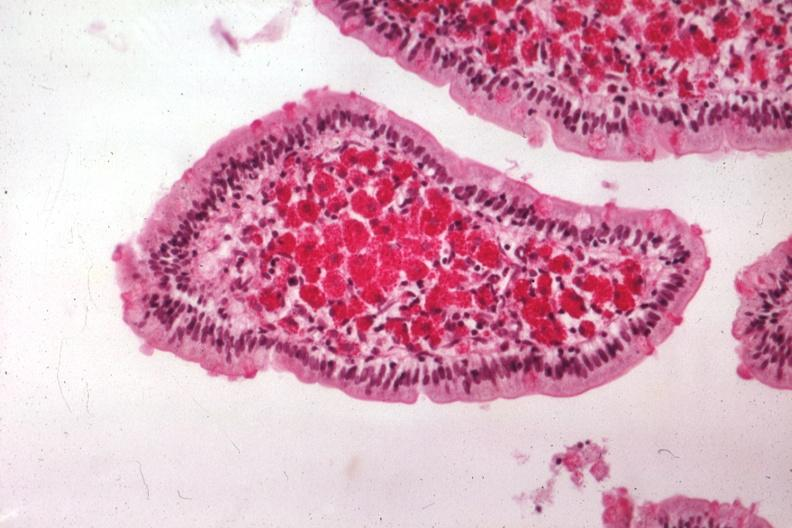what is present?
Answer the question using a single word or phrase. Intestine 